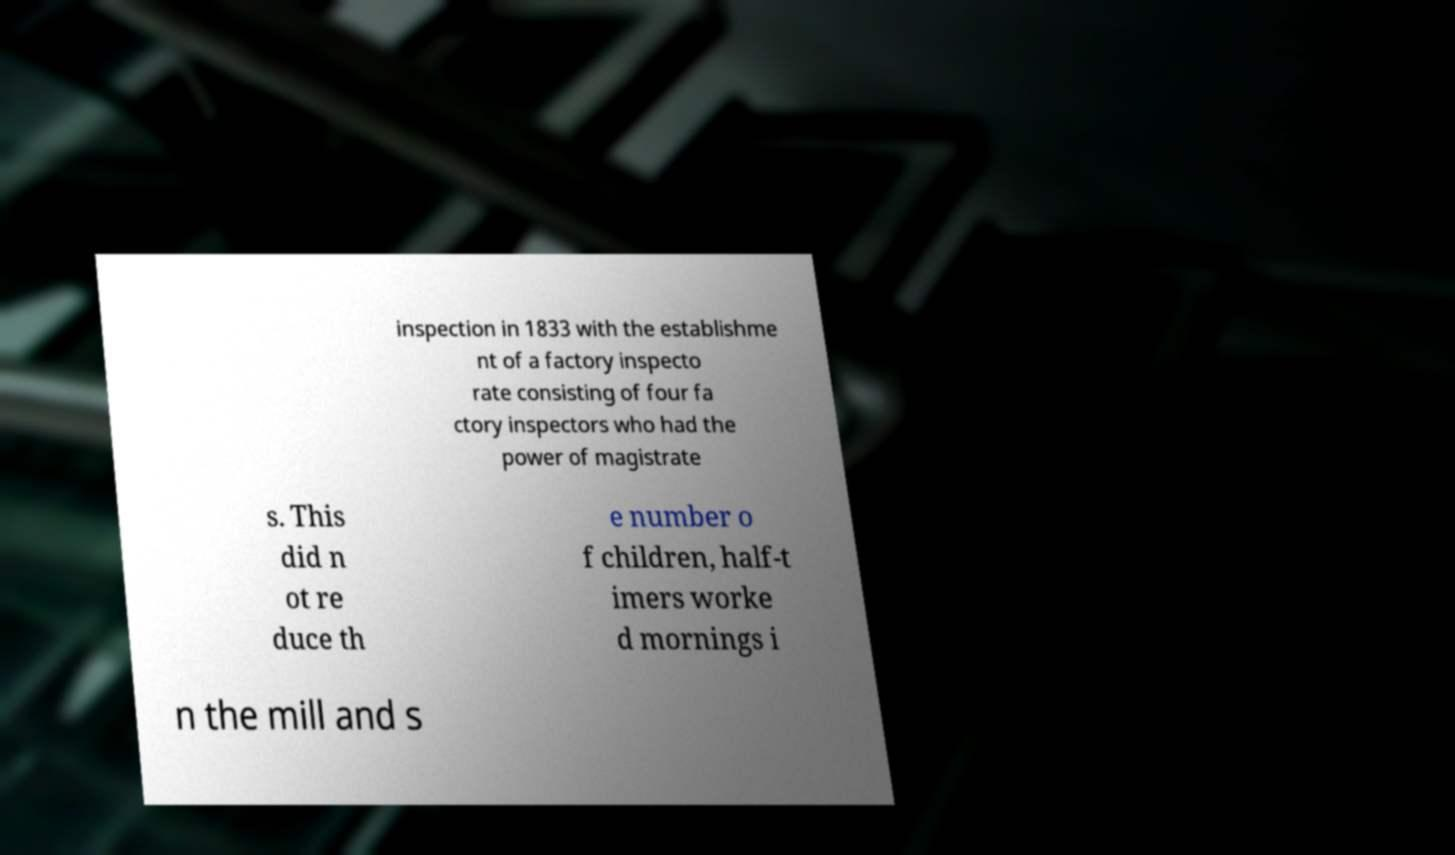Could you assist in decoding the text presented in this image and type it out clearly? inspection in 1833 with the establishme nt of a factory inspecto rate consisting of four fa ctory inspectors who had the power of magistrate s. This did n ot re duce th e number o f children, half-t imers worke d mornings i n the mill and s 